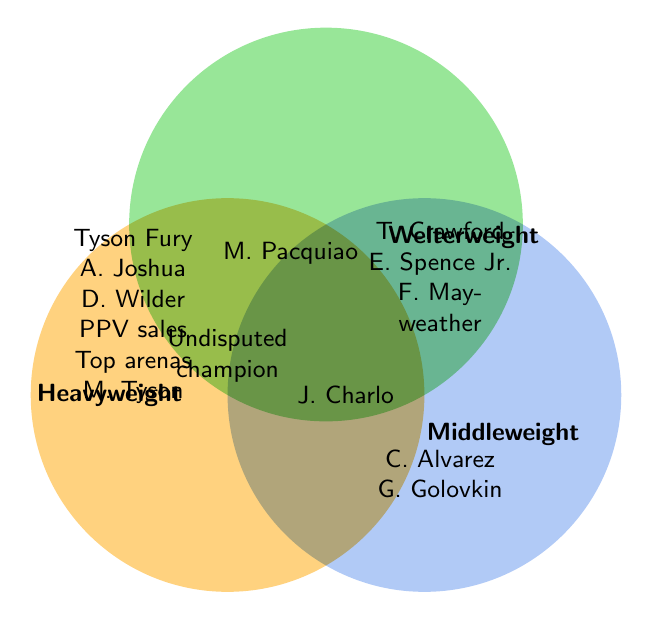Who are the boxers listed under the Heavyweight class? The Heavyweight class contains Tyson Fury, Anthony Joshua, and Deontay Wilder. This information is visually represented in the left circle of the Venn Diagram.
Answer: Tyson Fury, Anthony Joshua, Deontay Wilder Which weight class does Canelo Alvarez belong to? Canelo Alvarez is located in the region that overlaps with the Middleweight circle, which indicates he belongs to the Middleweight weight class.
Answer: Middleweight Which boxer is listed as an undisputed champion? The "Undisputed champion" label is positioned at the intersection point of all three weight classes, representing a shared area by Heavyweight, Welterweight, and Middleweight, without particular names.
Answer: No specific boxer named; the term is for all classes Which weight classes share Manny Pacquiao (legacy)? Manny Pacquiao (legacy) is situated where the circles of Heavyweight and Welterweight intersect, highlighting that he influences both these weight classes.
Answer: Heavyweight, Welterweight Who are the Charlo brothers listed, and which weight classes do they belong to? The Charlo brothers include Jermell Charlo in the overlapping region of Welterweight and Middleweight, and Jermall Charlo in the Middleweight circle.
Answer: Jermell Charlo (Welterweight, Middleweight), Jermall Charlo (Middleweight) What are the key features associated explicitly with the Heavyweight class? The features listed in the Heavyweight class's circle are Tyson Fury, Anthony Joshua, Deontay Wilder, Pay-per-view sales, Top arenas, and Mike Tyson (legacy).
Answer: Tyson Fury, Anthony Joshua, Deontay Wilder, PPV sales, Top arenas, Mike Tyson (legacy) Is Floyd Mayweather listed under more than one weight class? Floyd Mayweather is listed in the Welterweight circle alone, which means he does not belong to multiple weight classes as per the diagram.
Answer: No How many unique boxers are listed in the Middleweight class? The Middleweight class includes Canelo Alvarez, Gennady Golovkin, and Jermall Charlo. Counting these uniquely yields three boxers.
Answer: 3 What color represents the Welterweight weight class in the diagram? The color associated with Welterweight is a shade of green as depicted in its circle on the diagram.
Answer: Green How many boxers are shared between the Welterweight and Middleweight classes? Jermell Charlo is the only boxer listed at the intersection of the Welterweight and Middleweight classes, indicating he is shared between these two categories.
Answer: 1 